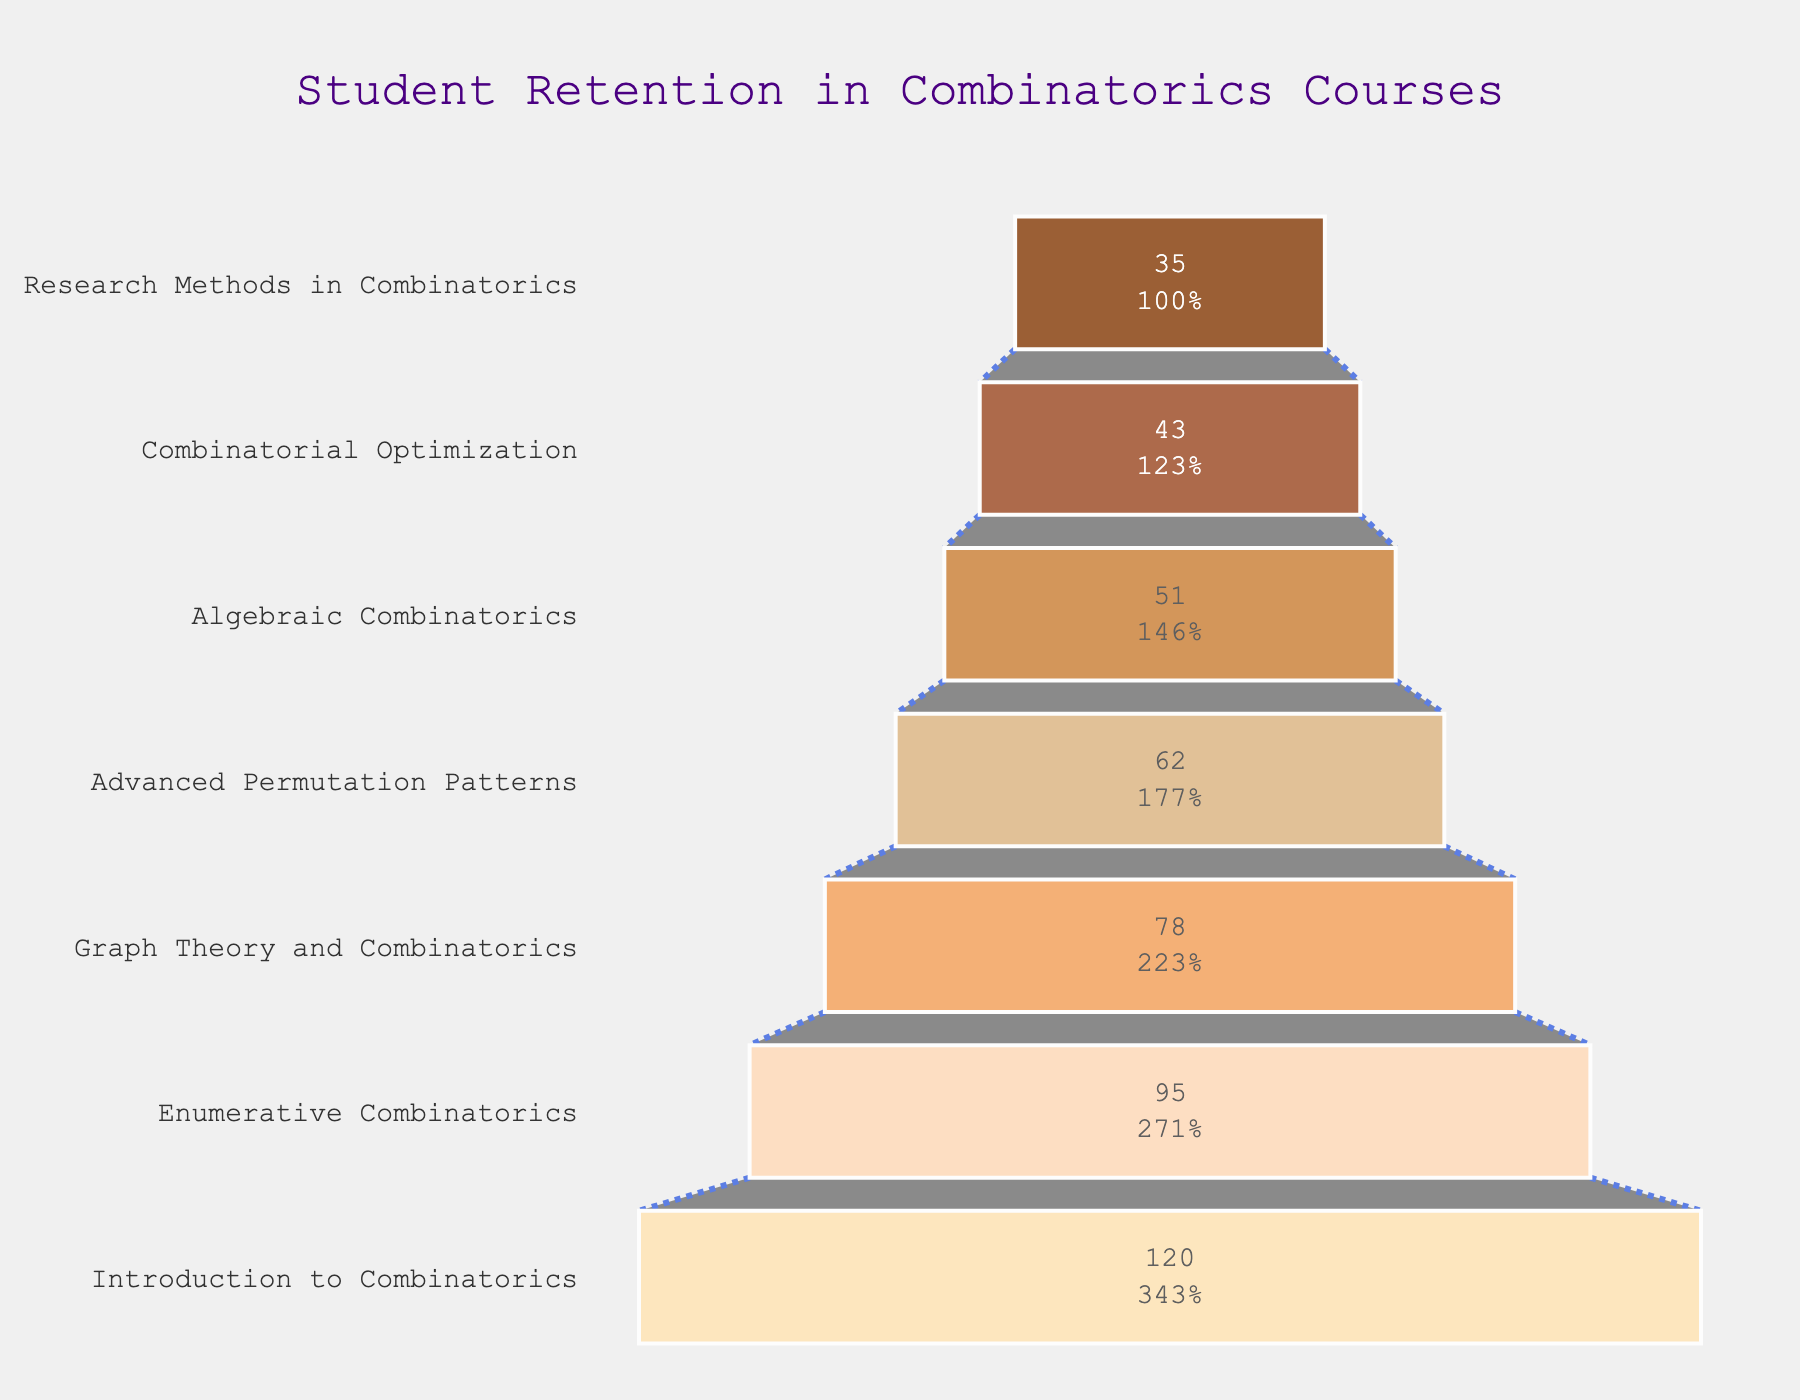What is the title of the funnel chart? The title is displayed prominently at the top of the figure in a larger font size and reads "Student Retention in Combinatorics Courses".
Answer: Student Retention in Combinatorics Courses How many courses are depicted in the funnel chart? By examining the y-axis labels on the funnel chart, there are seven distinct courses listed from "Introduction to Combinatorics" to "Research Methods in Combinatorics".
Answer: 7 Which course has the highest enrollment? The widest part of the funnel chart represents the highest value and corresponds to the course "Introduction to Combinatorics" with 120 students enrolled.
Answer: Introduction to Combinatorics What is the percentage retention from "Introduction to Combinatorics" to "Enumerative Combinatorics"? Calculate the percentage retention by dividing the number of students in "Enumerative Combinatorics" (95) by the number of students in "Introduction to Combinatorics" (120) and multiplying by 100. This is (95 / 120) * 100 = 79.17%.
Answer: 79.17% By how many students does enrollment decrease from "Graph Theory and Combinatorics" to "Advanced Permutation Patterns"? Subtract the number of students in "Advanced Permutation Patterns" (62) from those in "Graph Theory and Combinatorics" (78). The decrease is 78 - 62 = 16 students.
Answer: 16 students Which two courses have the smallest difference in student enrollment? Compare the number of students enrolled in each course. The smallest difference is between "Algebraic Combinatorics" (51) and "Combinatorial Optimization" (43) with a difference of 51 - 43 = 8 students.
Answer: Algebraic Combinatorics and Combinatorial Optimization What is the average number of students enrolled across all courses? Sum the number of students in all seven courses (120 + 95 + 78 + 62 + 51 + 43 + 35 = 484), then divide by the number of courses (484 / 7 ≈ 69.14).
Answer: Approximately 69.14 What percentage of students remain enrolled from "Enumerative Combinatorics" to "Research Methods in Combinatorics"? Calculate the percentage by dividing the number of students in "Research Methods in Combinatorics" (35) by those in "Enumerative Combinatorics" (95) and multiplying by 100. The calculation is (35 / 95) * 100 ≈ 36.84%.
Answer: 36.84% Which course demonstrates the largest dropout in terms of student numbers? Determine the course transitions with student numbers and find the largest difference. The largest dropout is from "Introduction to Combinatorics" (120) to "Enumerative Combinatorics" (95), a difference of 120 - 95 = 25 students.
Answer: Introduction to Combinatorics to Enumerative Combinatorics 